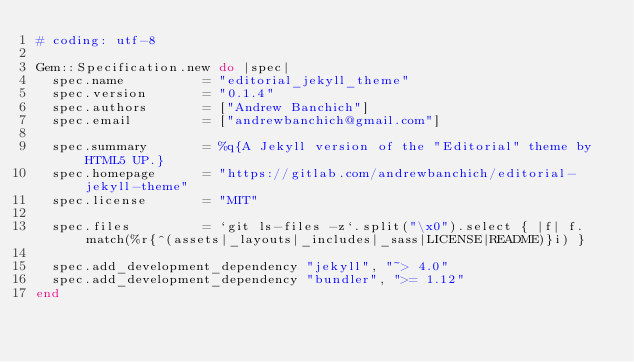Convert code to text. <code><loc_0><loc_0><loc_500><loc_500><_Ruby_># coding: utf-8

Gem::Specification.new do |spec|
  spec.name          = "editorial_jekyll_theme"
  spec.version       = "0.1.4"
  spec.authors       = ["Andrew Banchich"]
  spec.email         = ["andrewbanchich@gmail.com"]

  spec.summary       = %q{A Jekyll version of the "Editorial" theme by HTML5 UP.}
  spec.homepage      = "https://gitlab.com/andrewbanchich/editorial-jekyll-theme"
  spec.license       = "MIT"

  spec.files         = `git ls-files -z`.split("\x0").select { |f| f.match(%r{^(assets|_layouts|_includes|_sass|LICENSE|README)}i) }

  spec.add_development_dependency "jekyll", "~> 4.0"
  spec.add_development_dependency "bundler", ">= 1.12"
end
</code> 